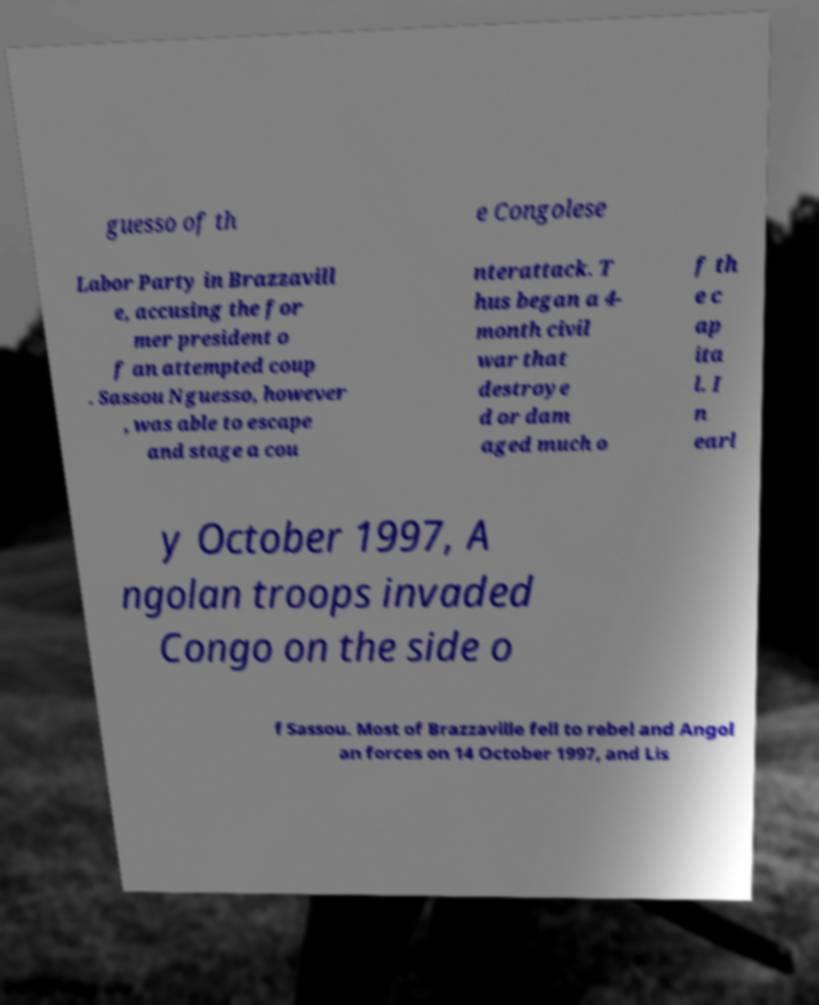Can you read and provide the text displayed in the image?This photo seems to have some interesting text. Can you extract and type it out for me? guesso of th e Congolese Labor Party in Brazzavill e, accusing the for mer president o f an attempted coup . Sassou Nguesso, however , was able to escape and stage a cou nterattack. T hus began a 4- month civil war that destroye d or dam aged much o f th e c ap ita l. I n earl y October 1997, A ngolan troops invaded Congo on the side o f Sassou. Most of Brazzaville fell to rebel and Angol an forces on 14 October 1997, and Lis 